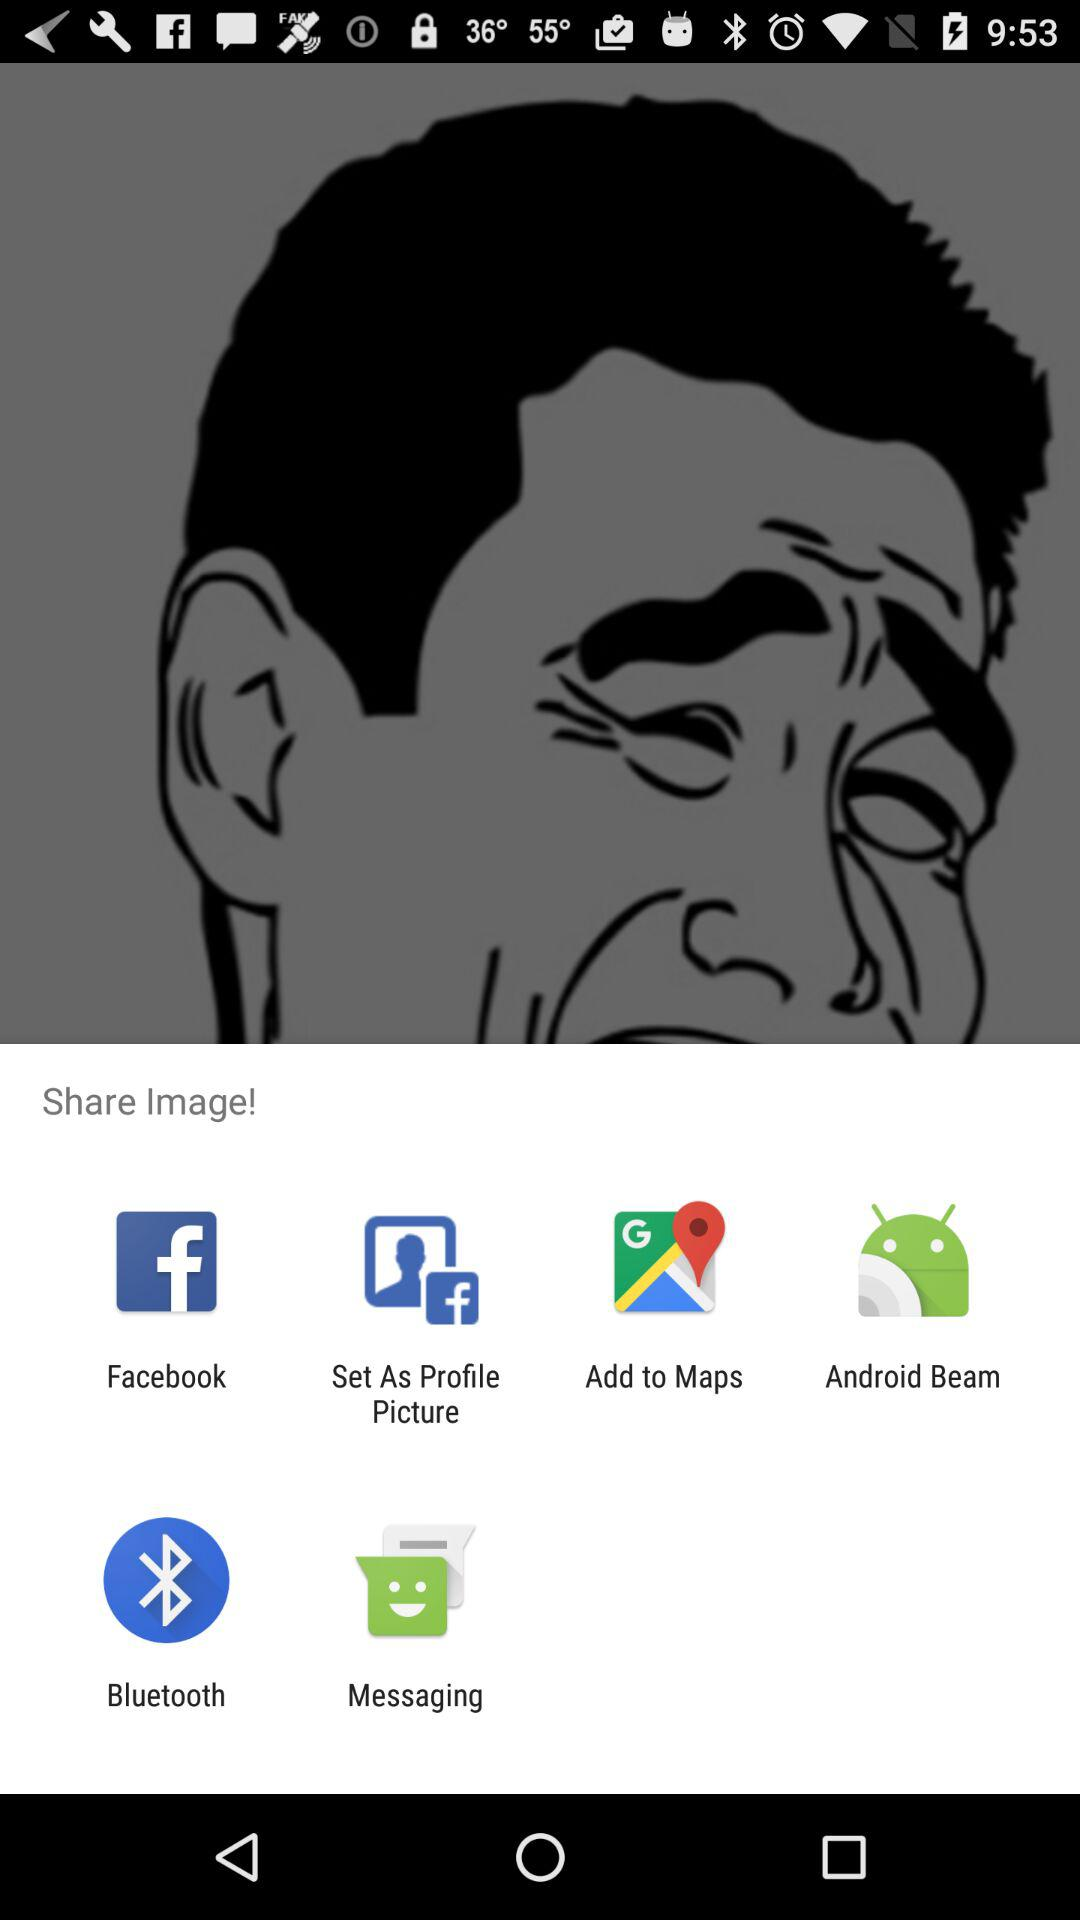Which application can I use to share the image? You can use "Facebook", "Set As Profile Picture", "Add to Maps", "Android Beam", "Bluetooth" and "Messaging" applications to share the image. 